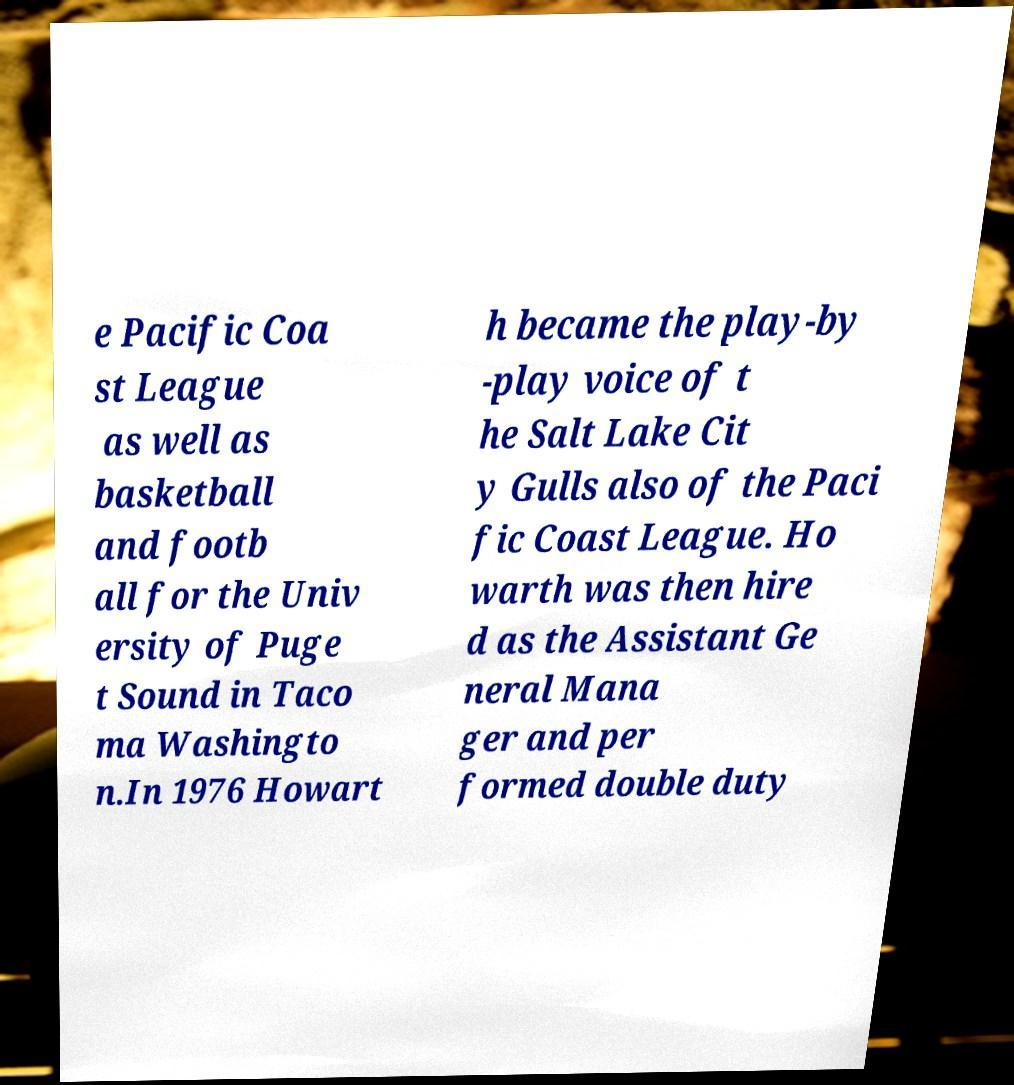Can you accurately transcribe the text from the provided image for me? e Pacific Coa st League as well as basketball and footb all for the Univ ersity of Puge t Sound in Taco ma Washingto n.In 1976 Howart h became the play-by -play voice of t he Salt Lake Cit y Gulls also of the Paci fic Coast League. Ho warth was then hire d as the Assistant Ge neral Mana ger and per formed double duty 